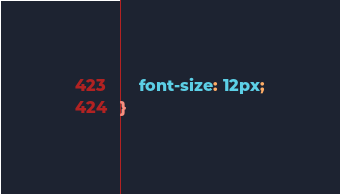<code> <loc_0><loc_0><loc_500><loc_500><_CSS_>    font-size: 12px;
}</code> 